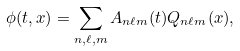Convert formula to latex. <formula><loc_0><loc_0><loc_500><loc_500>\phi ( t , x ) = \sum _ { n , \ell , m } A _ { n \ell m } ( t ) Q _ { n \ell m } ( x ) ,</formula> 